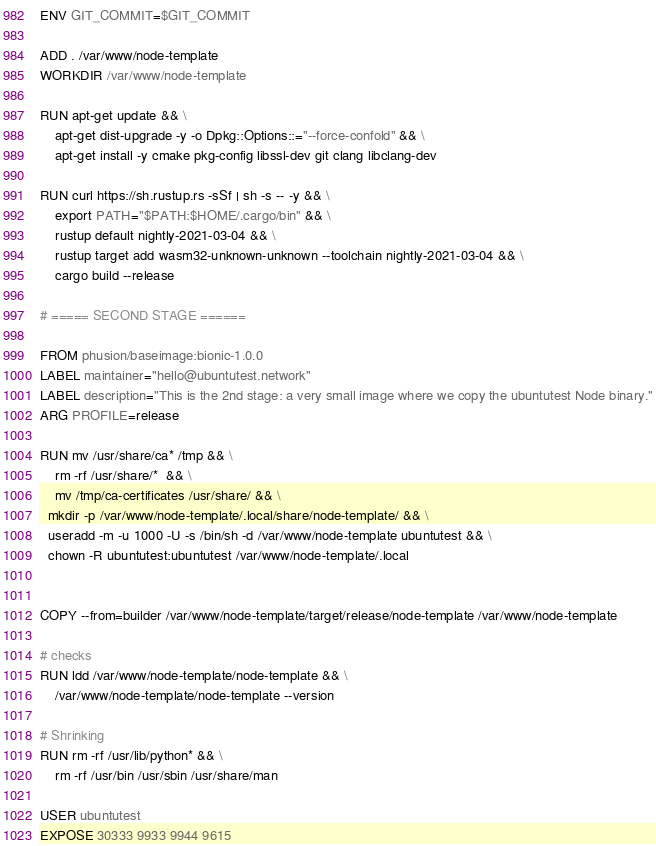<code> <loc_0><loc_0><loc_500><loc_500><_Dockerfile_>ENV GIT_COMMIT=$GIT_COMMIT

ADD . /var/www/node-template
WORKDIR /var/www/node-template

RUN apt-get update && \
	apt-get dist-upgrade -y -o Dpkg::Options::="--force-confold" && \
	apt-get install -y cmake pkg-config libssl-dev git clang libclang-dev

RUN curl https://sh.rustup.rs -sSf | sh -s -- -y && \
	export PATH="$PATH:$HOME/.cargo/bin" && \
	rustup default nightly-2021-03-04 && \
	rustup target add wasm32-unknown-unknown --toolchain nightly-2021-03-04 && \
	cargo build --release

# ===== SECOND STAGE ======

FROM phusion/baseimage:bionic-1.0.0
LABEL maintainer="hello@ubuntutest.network"
LABEL description="This is the 2nd stage: a very small image where we copy the ubuntutest Node binary."
ARG PROFILE=release

RUN mv /usr/share/ca* /tmp && \
	rm -rf /usr/share/*  && \
	mv /tmp/ca-certificates /usr/share/ && \
  mkdir -p /var/www/node-template/.local/share/node-template/ && \
  useradd -m -u 1000 -U -s /bin/sh -d /var/www/node-template ubuntutest && \
  chown -R ubuntutest:ubuntutest /var/www/node-template/.local


COPY --from=builder /var/www/node-template/target/release/node-template /var/www/node-template

# checks
RUN ldd /var/www/node-template/node-template && \
	/var/www/node-template/node-template --version

# Shrinking
RUN rm -rf /usr/lib/python* && \
	rm -rf /usr/bin /usr/sbin /usr/share/man

USER ubuntutest
EXPOSE 30333 9933 9944 9615
</code> 